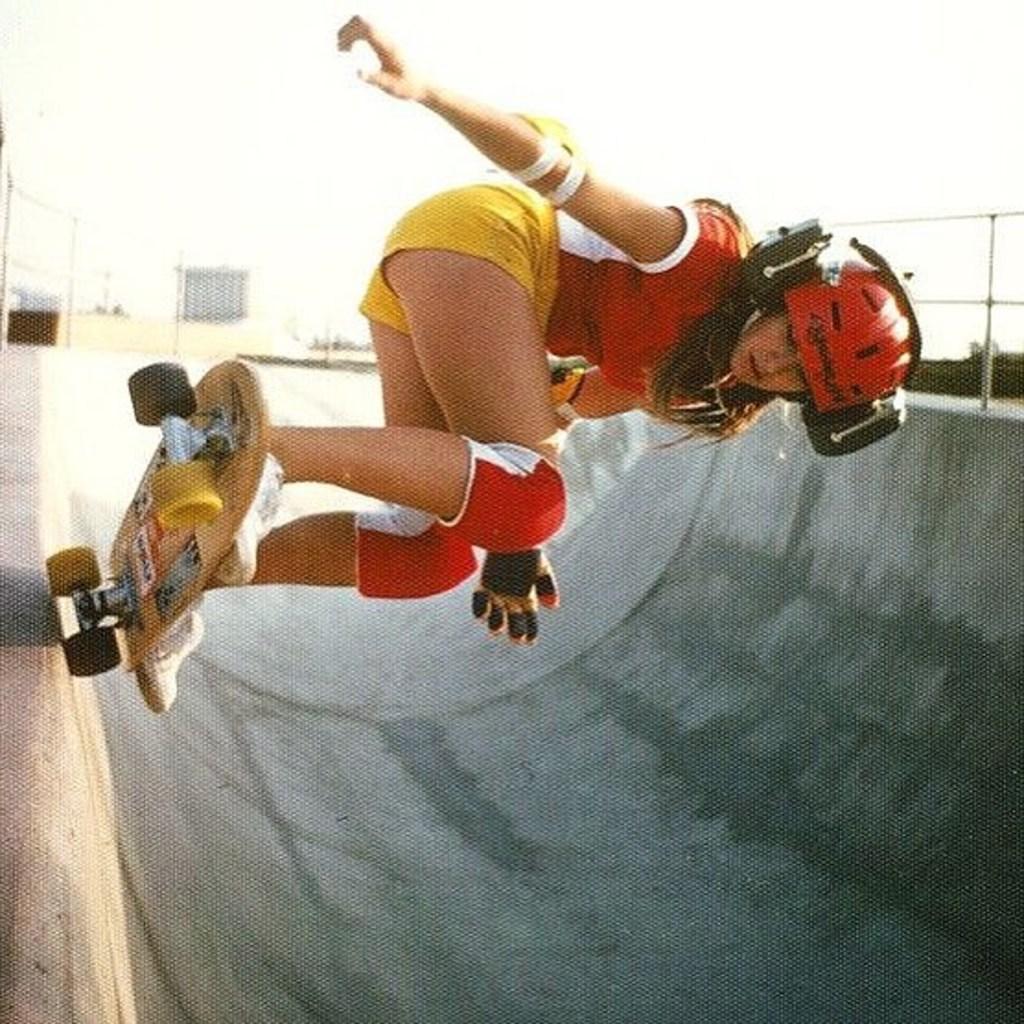How would you summarize this image in a sentence or two? In this image I can see a woman is doing skating on a skateboard. The woman is wearing a helmet, knee pads and shoes. In the background I can see the sky and a building. 